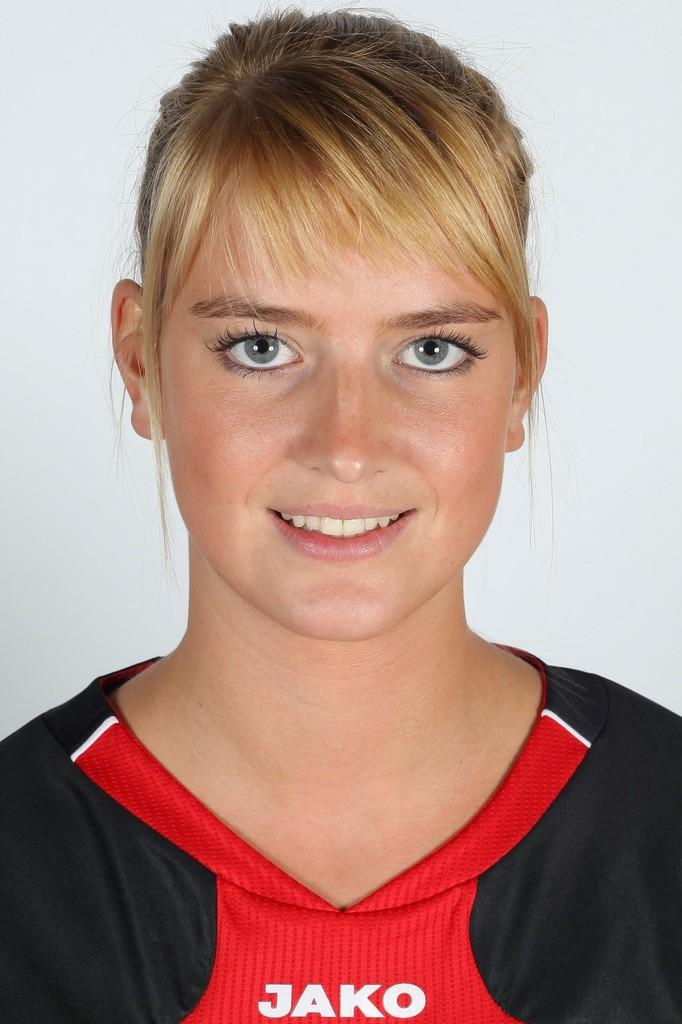<image>
Give a short and clear explanation of the subsequent image. The woman is staring at the camera and wearing a Jako shirt. 